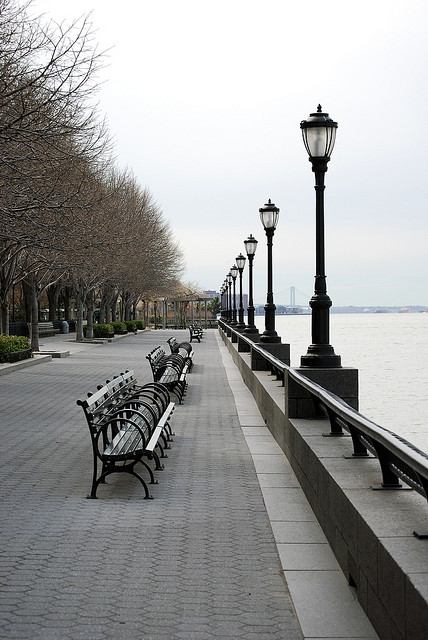<image>What powers the lamps? I am not sure what powers the lamps. It could be either gas or electricity. What powers the lamps? I am not sure what powers the lamps. It can be powered by gas, electricity, or even by the sun. 